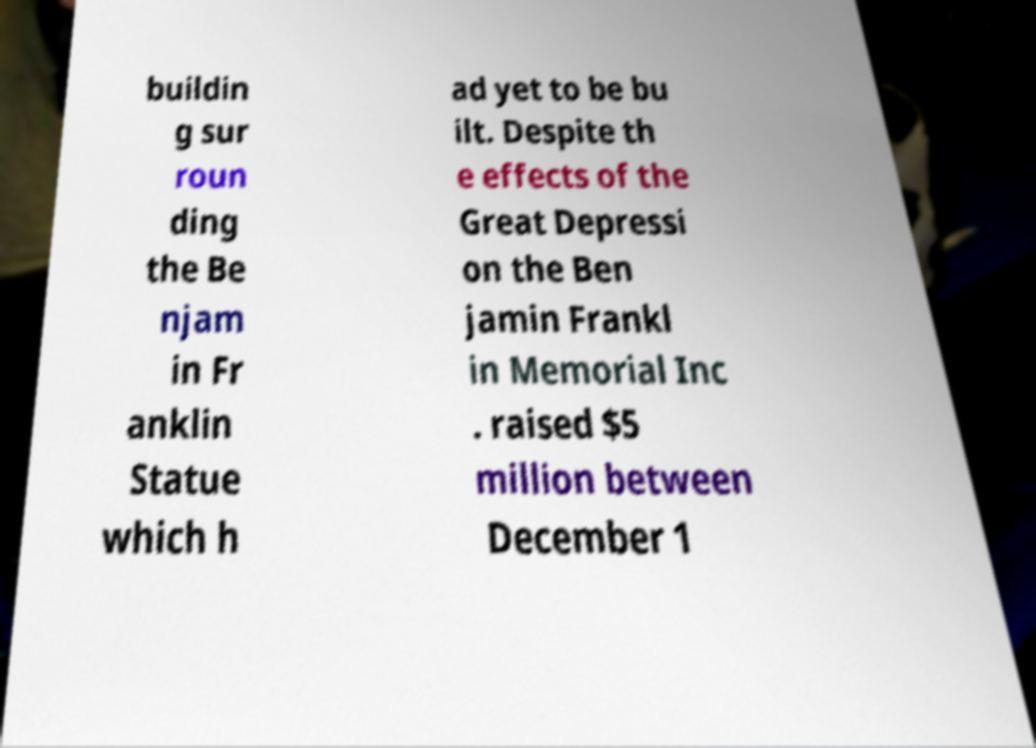Please identify and transcribe the text found in this image. buildin g sur roun ding the Be njam in Fr anklin Statue which h ad yet to be bu ilt. Despite th e effects of the Great Depressi on the Ben jamin Frankl in Memorial Inc . raised $5 million between December 1 